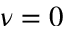Convert formula to latex. <formula><loc_0><loc_0><loc_500><loc_500>\nu = 0</formula> 